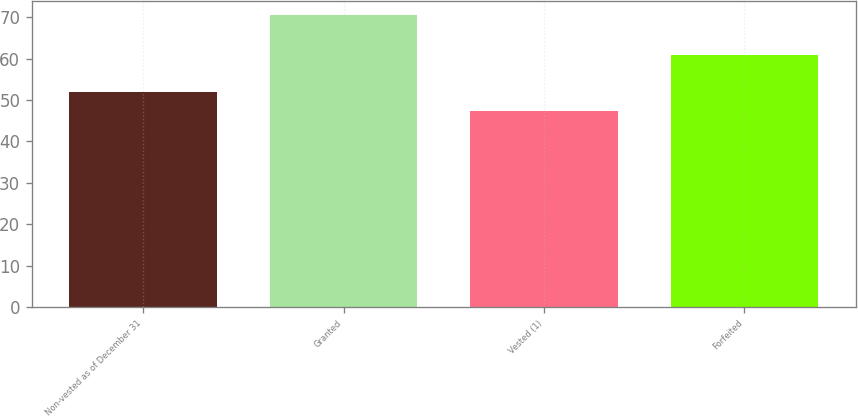<chart> <loc_0><loc_0><loc_500><loc_500><bar_chart><fcel>Non-vested as of December 31<fcel>Granted<fcel>Vested (1)<fcel>Forfeited<nl><fcel>52.03<fcel>70.42<fcel>47.43<fcel>60.77<nl></chart> 